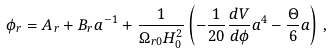<formula> <loc_0><loc_0><loc_500><loc_500>\phi _ { r } = A _ { r } + B _ { r } a ^ { - 1 } + \frac { 1 } { \Omega _ { r 0 } H _ { 0 } ^ { 2 } } \left ( - \frac { 1 } { 2 0 } \frac { d V } { d \phi } a ^ { 4 } - \frac { \Theta } { 6 } a \right ) \, ,</formula> 